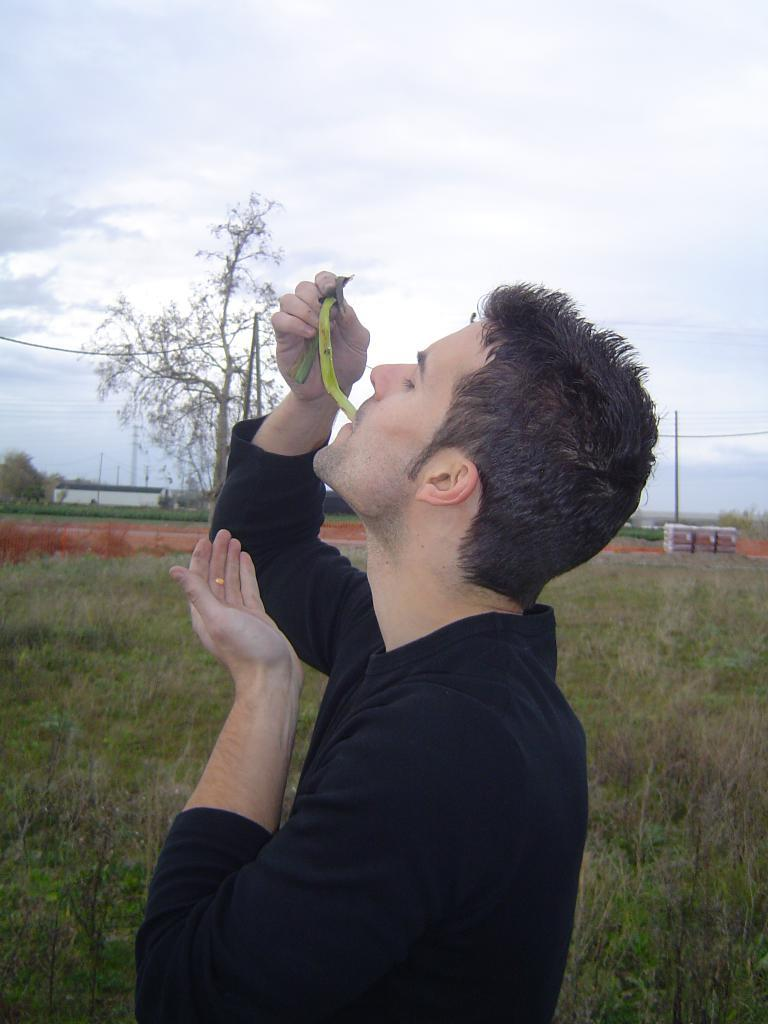Who is the person in the image? There is a man in the picture. What is the man doing in the image? The man is eating. What type of surface is the man standing on? There is grass on the floor. What can be seen in the background of the image? There is a tree and a building in the background. What is the condition of the sky in the image? The sky is clear. What type of rule does the man use to measure the length of the sock in the image? There is no rule or sock present in the image. 